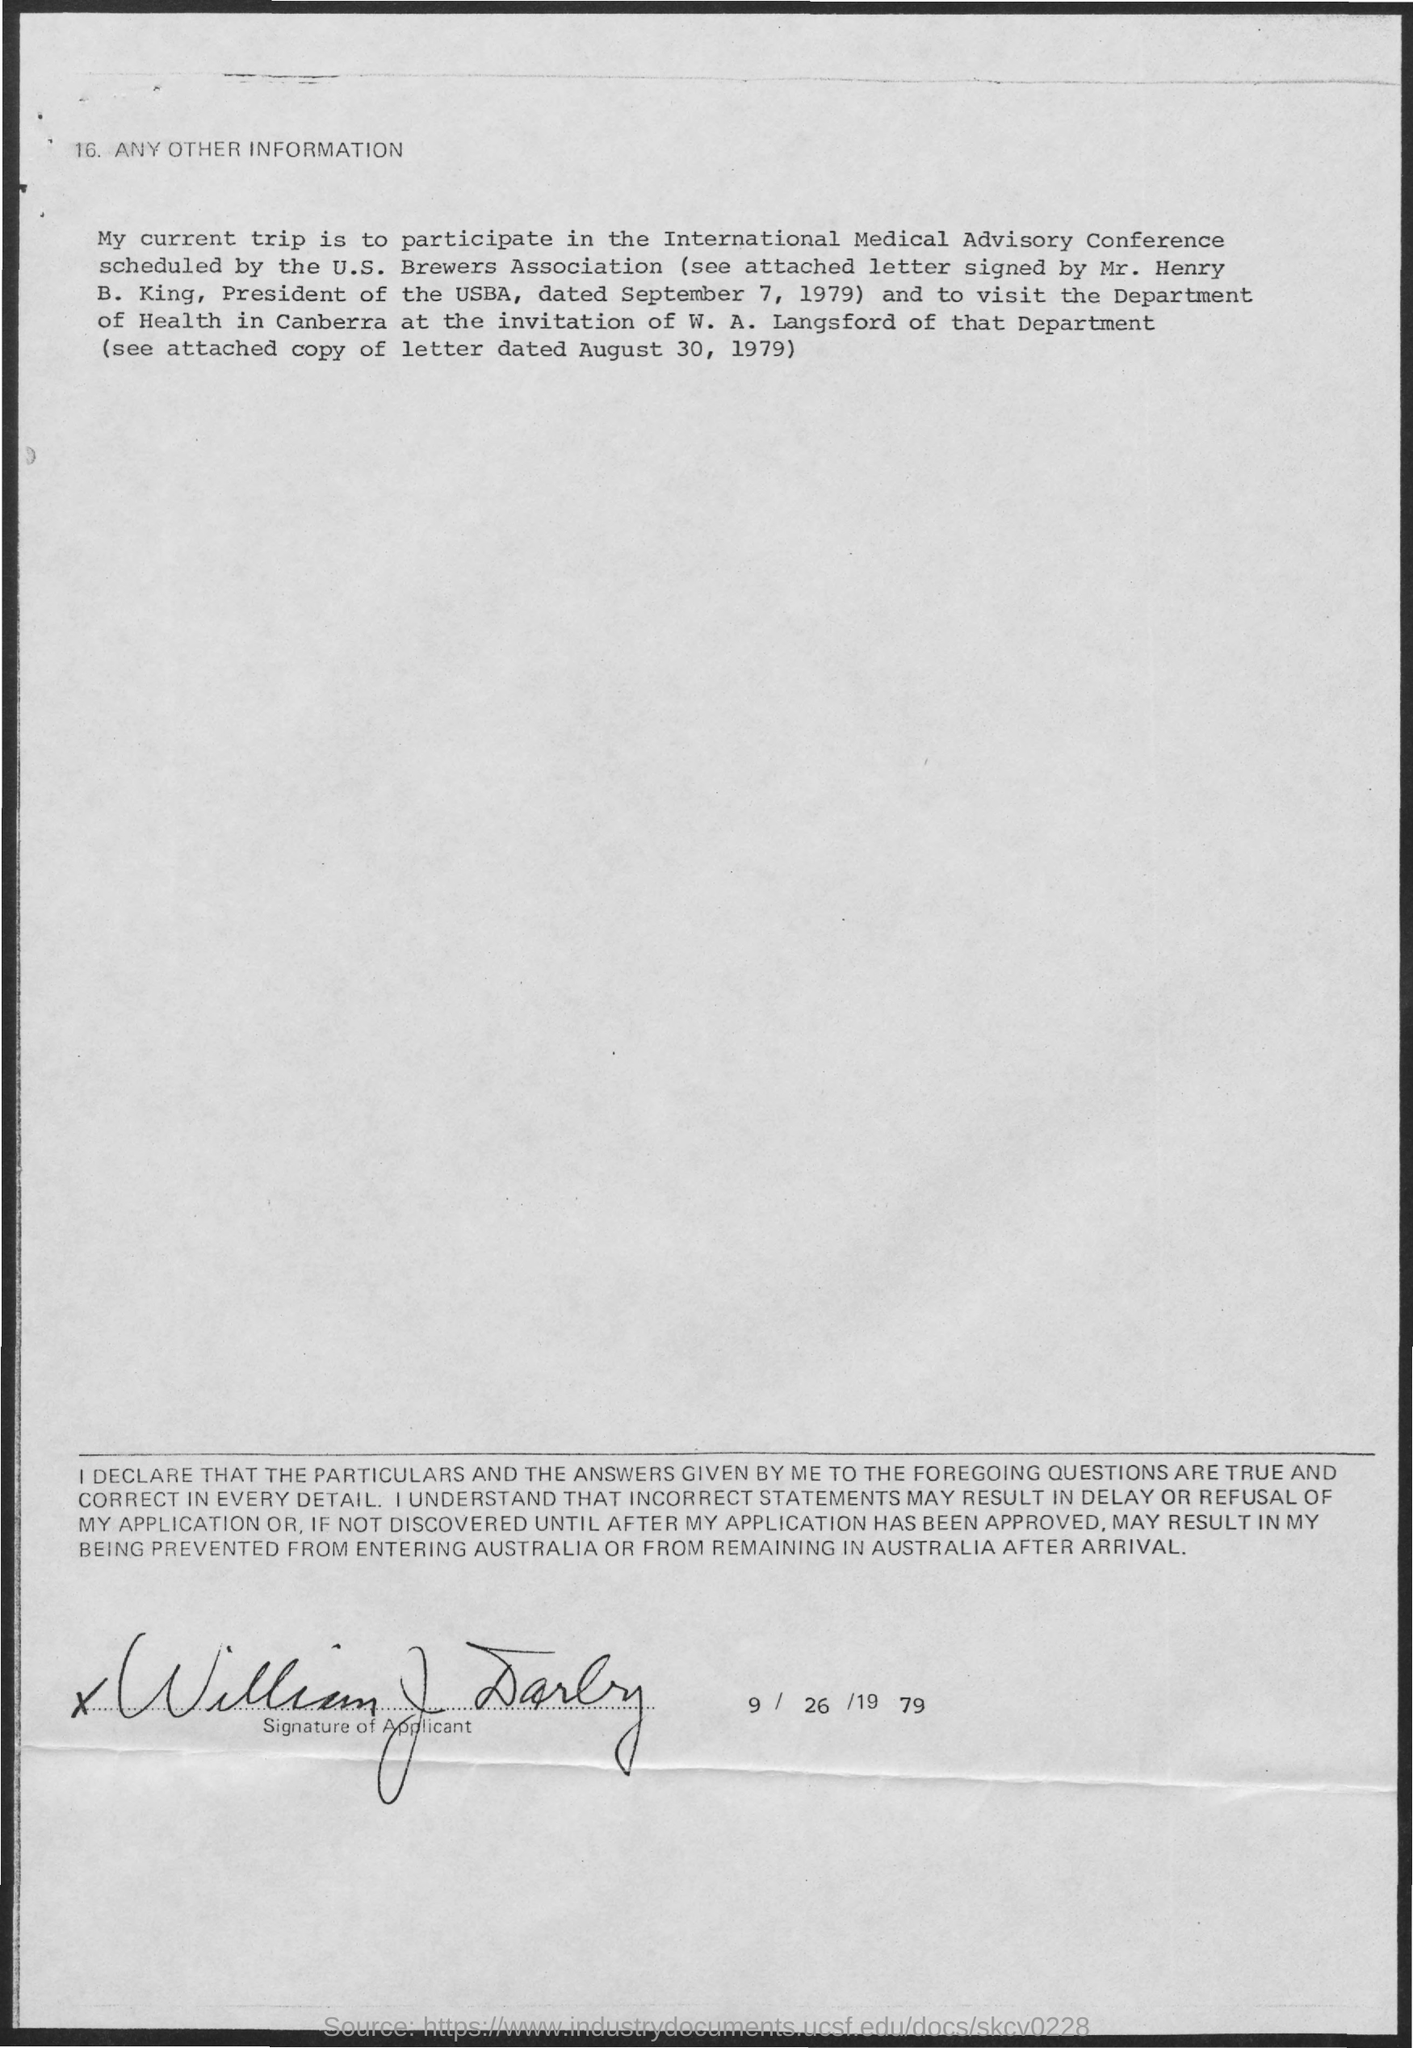Indicate a few pertinent items in this graphic. The U.S. Brewers Association has scheduled the International Medical Advisory Conference. The attached letter has been signed by Mr. Henry B. King. W. A. Langsford belongs to the department of health. Mr. Henry is the President of the USBA. The attached letter, signed by Mr. Henry on September 7, 1979, is a declaration. 